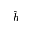<formula> <loc_0><loc_0><loc_500><loc_500>\widehat { h }</formula> 